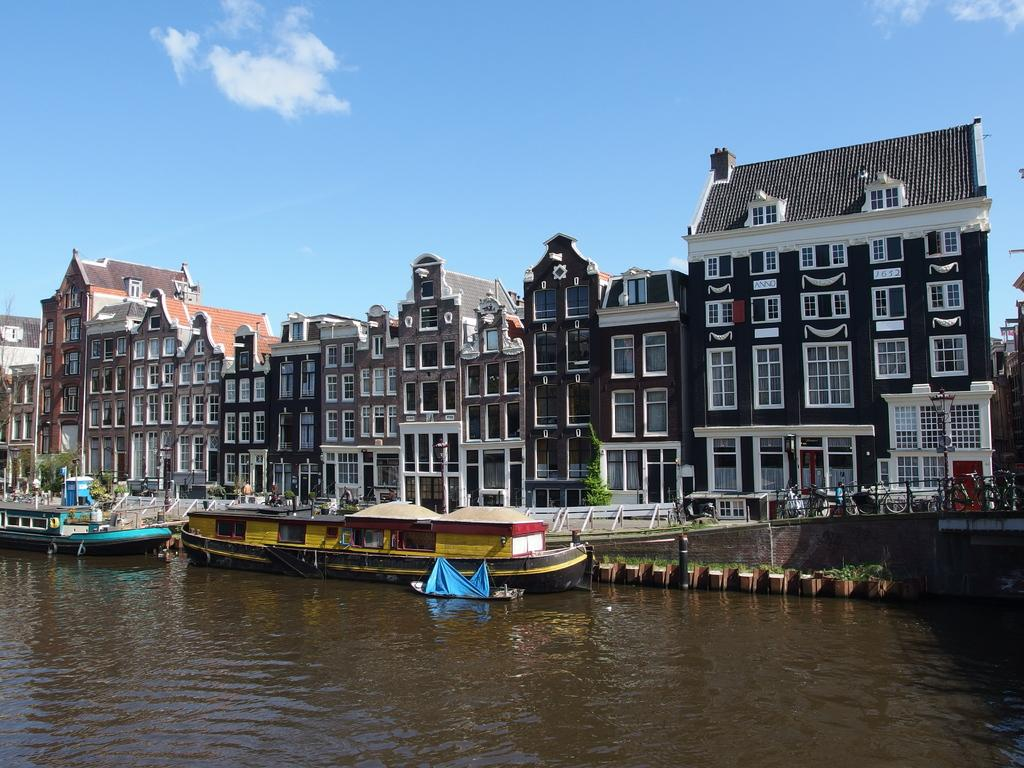What is on the water in the image? There are boats on the water in the image. What can be seen in the background of the image? There are people, buildings, and trees in the background of the image. What type of soap is being used by the bear in the image? There is no bear or soap present in the image. Can you describe the smile on the bear's face in the image? There is no bear or smile present in the image. 